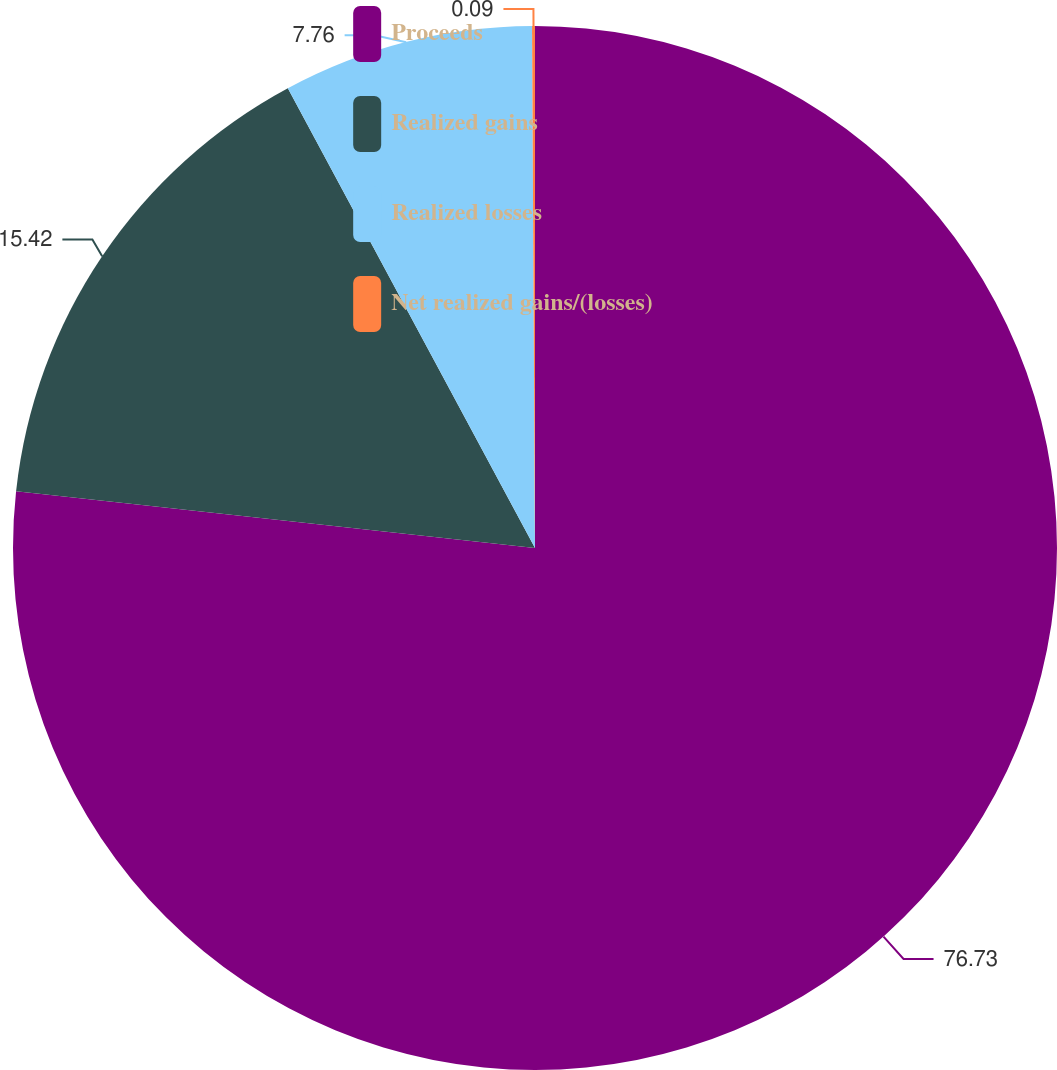<chart> <loc_0><loc_0><loc_500><loc_500><pie_chart><fcel>Proceeds<fcel>Realized gains<fcel>Realized losses<fcel>Net realized gains/(losses)<nl><fcel>76.73%<fcel>15.42%<fcel>7.76%<fcel>0.09%<nl></chart> 